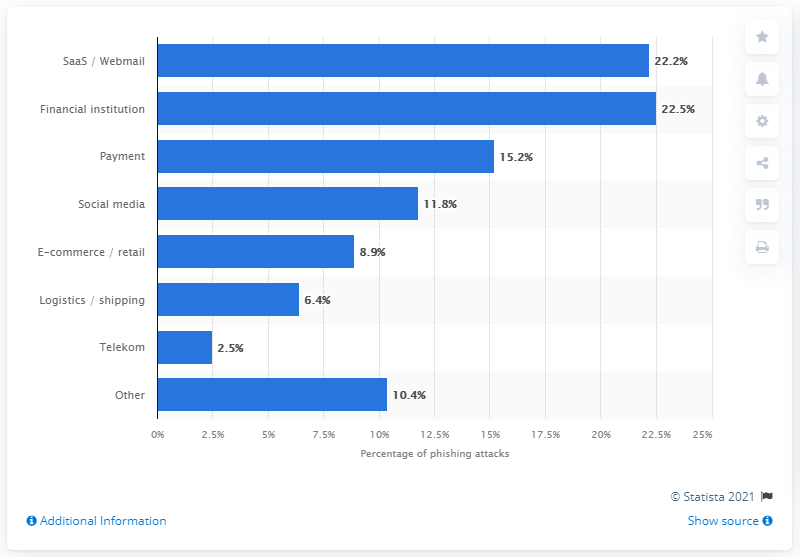Point out several critical features in this image. In the fourth quarter of 2020, approximately 22.2% of phishing attacks targeted SaaS and webmail services. 